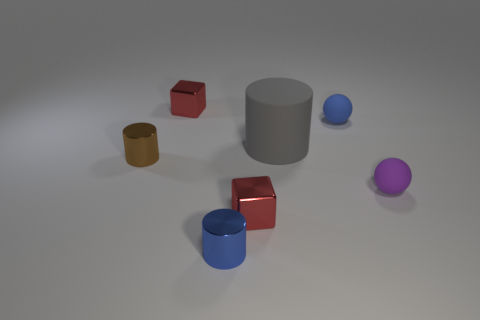What size is the gray rubber object that is the same shape as the brown shiny object?
Provide a short and direct response. Large. There is a cylinder that is right of the brown cylinder and behind the tiny blue shiny cylinder; what size is it?
Your answer should be compact. Large. How many yellow objects are small blocks or objects?
Keep it short and to the point. 0. What is the shape of the gray thing?
Your answer should be very brief. Cylinder. How many other things are the same shape as the big gray object?
Provide a short and direct response. 2. There is a cube that is behind the gray cylinder; what is its color?
Provide a succinct answer. Red. Does the tiny blue sphere have the same material as the purple thing?
Your answer should be very brief. Yes. What number of things are cyan spheres or tiny metal things in front of the brown shiny thing?
Your answer should be very brief. 2. The tiny blue thing behind the big thing has what shape?
Provide a succinct answer. Sphere. Does the cylinder that is in front of the tiny purple matte thing have the same color as the large matte thing?
Offer a very short reply. No. 